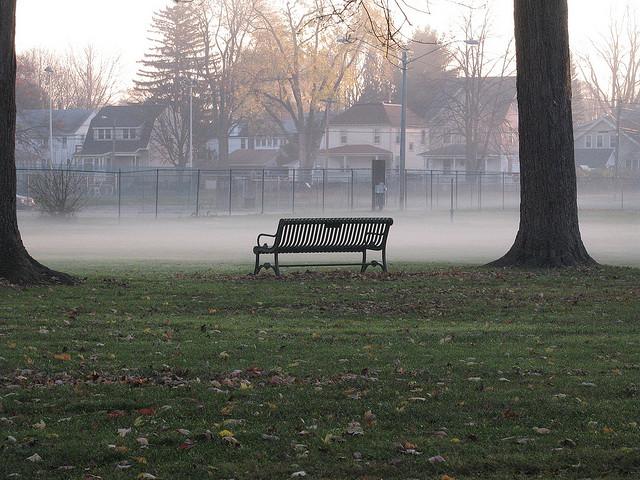How long has this bench been sitting in this place in this park?
Give a very brief answer. Long time. Is there a likely high humidity in this area right now?
Be succinct. Yes. Is it foggy in the park?
Give a very brief answer. Yes. 